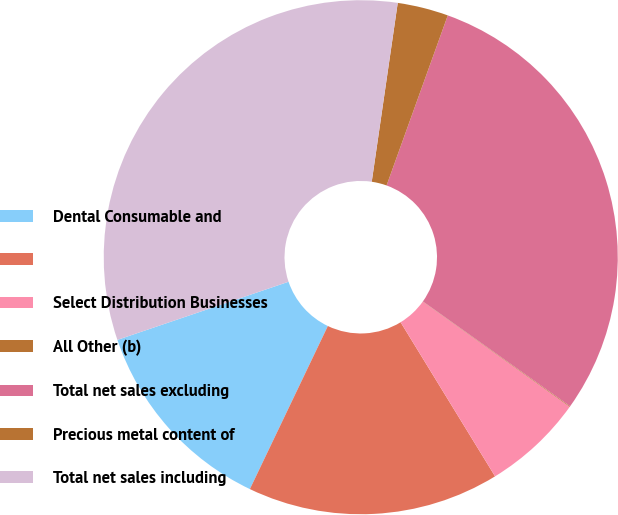Convert chart. <chart><loc_0><loc_0><loc_500><loc_500><pie_chart><fcel>Dental Consumable and<fcel>Unnamed: 1<fcel>Select Distribution Businesses<fcel>All Other (b)<fcel>Total net sales excluding<fcel>Precious metal content of<fcel>Total net sales including<nl><fcel>12.69%<fcel>15.85%<fcel>6.36%<fcel>0.04%<fcel>29.35%<fcel>3.2%<fcel>32.51%<nl></chart> 